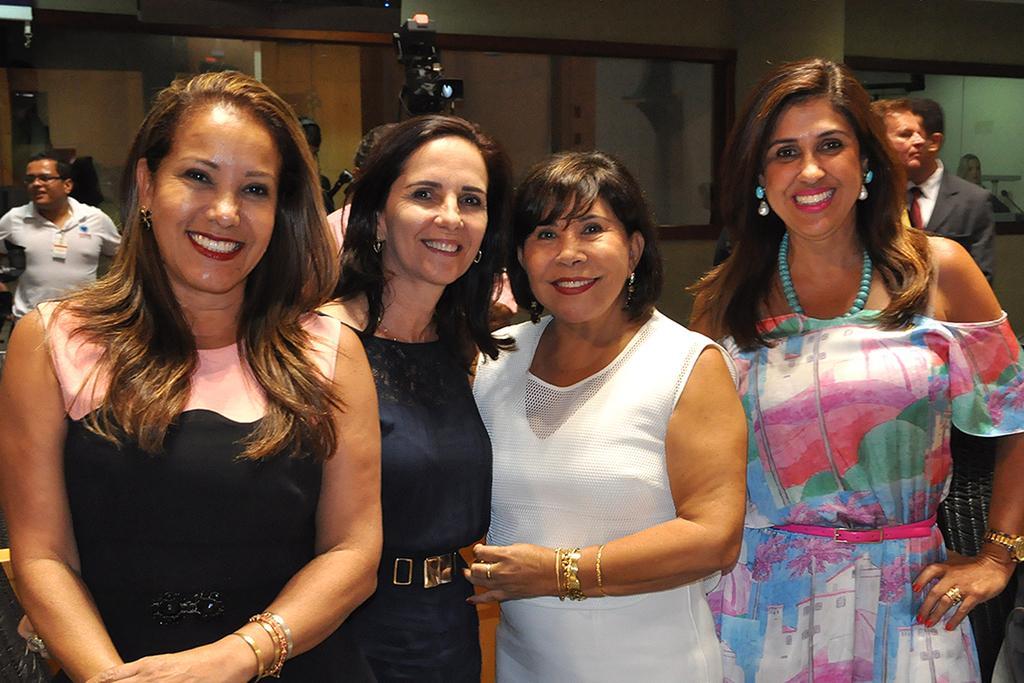How would you summarize this image in a sentence or two? In this image we can see women smiling and standing on the floor. In the background there are men standing on the floor, cameras and walls. 